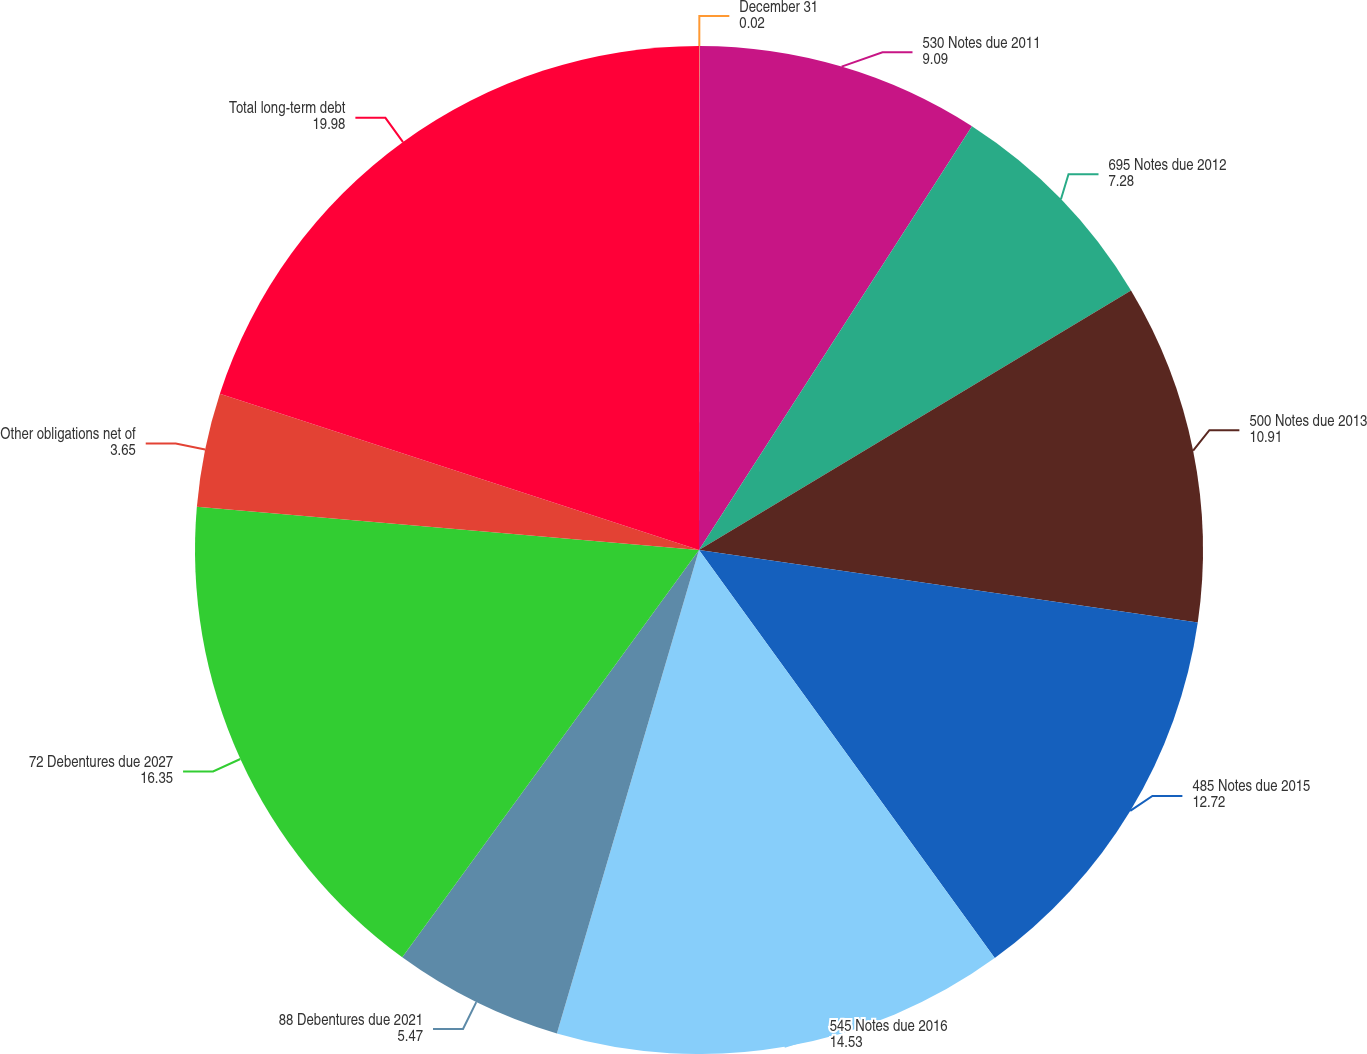Convert chart. <chart><loc_0><loc_0><loc_500><loc_500><pie_chart><fcel>December 31<fcel>530 Notes due 2011<fcel>695 Notes due 2012<fcel>500 Notes due 2013<fcel>485 Notes due 2015<fcel>545 Notes due 2016<fcel>88 Debentures due 2021<fcel>72 Debentures due 2027<fcel>Other obligations net of<fcel>Total long-term debt<nl><fcel>0.02%<fcel>9.09%<fcel>7.28%<fcel>10.91%<fcel>12.72%<fcel>14.53%<fcel>5.47%<fcel>16.35%<fcel>3.65%<fcel>19.98%<nl></chart> 